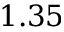<formula> <loc_0><loc_0><loc_500><loc_500>1 . 3 5</formula> 